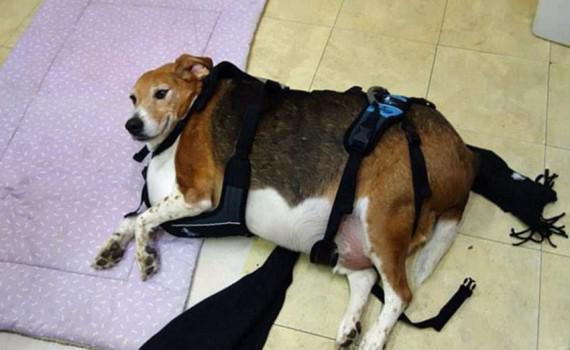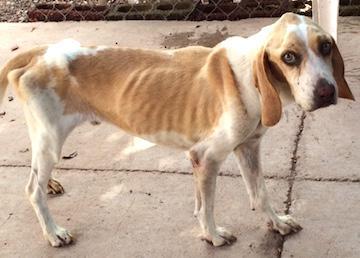The first image is the image on the left, the second image is the image on the right. For the images shown, is this caption "A dog has its tongue visible while looking at the camera." true? Answer yes or no. No. The first image is the image on the left, the second image is the image on the right. For the images shown, is this caption "Right image shows a camera-facing beagle with its tongue at least partly showing." true? Answer yes or no. No. 